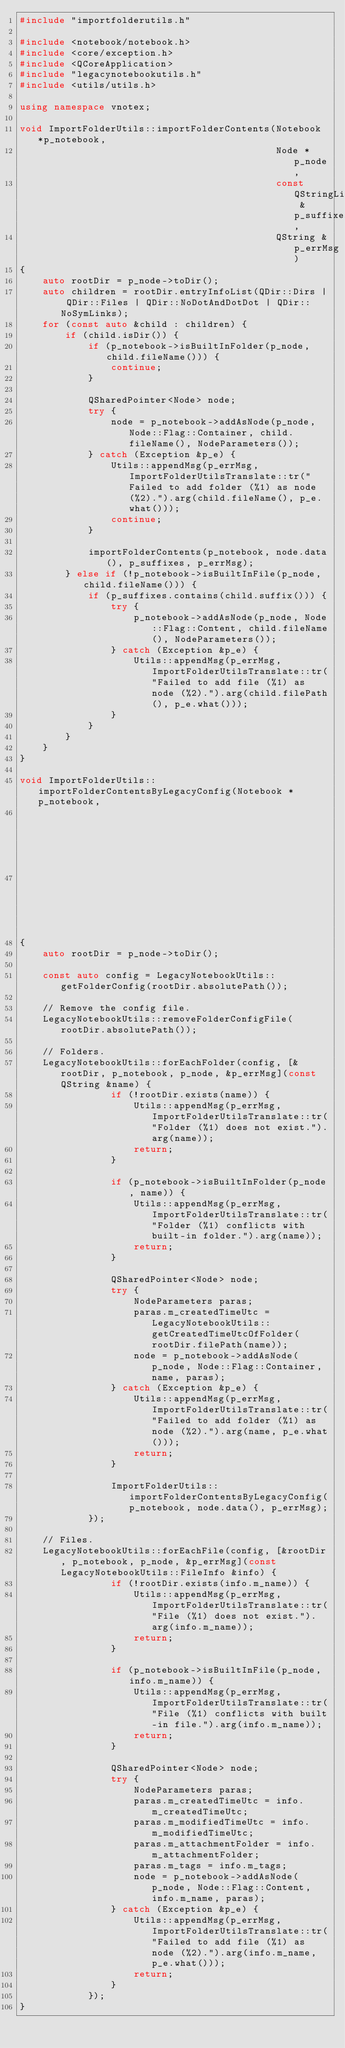<code> <loc_0><loc_0><loc_500><loc_500><_C++_>#include "importfolderutils.h"

#include <notebook/notebook.h>
#include <core/exception.h>
#include <QCoreApplication>
#include "legacynotebookutils.h"
#include <utils/utils.h>

using namespace vnotex;

void ImportFolderUtils::importFolderContents(Notebook *p_notebook,
                                             Node *p_node,
                                             const QStringList &p_suffixes,
                                             QString &p_errMsg)
{
    auto rootDir = p_node->toDir();
    auto children = rootDir.entryInfoList(QDir::Dirs | QDir::Files | QDir::NoDotAndDotDot | QDir::NoSymLinks);
    for (const auto &child : children) {
        if (child.isDir()) {
            if (p_notebook->isBuiltInFolder(p_node, child.fileName())) {
                continue;
            }

            QSharedPointer<Node> node;
            try {
                node = p_notebook->addAsNode(p_node, Node::Flag::Container, child.fileName(), NodeParameters());
            } catch (Exception &p_e) {
                Utils::appendMsg(p_errMsg, ImportFolderUtilsTranslate::tr("Failed to add folder (%1) as node (%2).").arg(child.fileName(), p_e.what()));
                continue;
            }

            importFolderContents(p_notebook, node.data(), p_suffixes, p_errMsg);
        } else if (!p_notebook->isBuiltInFile(p_node, child.fileName())) {
            if (p_suffixes.contains(child.suffix())) {
                try {
                    p_notebook->addAsNode(p_node, Node::Flag::Content, child.fileName(), NodeParameters());
                } catch (Exception &p_e) {
                    Utils::appendMsg(p_errMsg, ImportFolderUtilsTranslate::tr("Failed to add file (%1) as node (%2).").arg(child.filePath(), p_e.what()));
                }
            }
        }
    }
}

void ImportFolderUtils::importFolderContentsByLegacyConfig(Notebook *p_notebook,
                                                           Node *p_node,
                                                           QString &p_errMsg)
{
    auto rootDir = p_node->toDir();

    const auto config = LegacyNotebookUtils::getFolderConfig(rootDir.absolutePath());

    // Remove the config file.
    LegacyNotebookUtils::removeFolderConfigFile(rootDir.absolutePath());

    // Folders.
    LegacyNotebookUtils::forEachFolder(config, [&rootDir, p_notebook, p_node, &p_errMsg](const QString &name) {
                if (!rootDir.exists(name)) {
                    Utils::appendMsg(p_errMsg, ImportFolderUtilsTranslate::tr("Folder (%1) does not exist.").arg(name));
                    return;
                }

                if (p_notebook->isBuiltInFolder(p_node, name)) {
                    Utils::appendMsg(p_errMsg, ImportFolderUtilsTranslate::tr("Folder (%1) conflicts with built-in folder.").arg(name));
                    return;
                }

                QSharedPointer<Node> node;
                try {
                    NodeParameters paras;
                    paras.m_createdTimeUtc = LegacyNotebookUtils::getCreatedTimeUtcOfFolder(rootDir.filePath(name));
                    node = p_notebook->addAsNode(p_node, Node::Flag::Container, name, paras);
                } catch (Exception &p_e) {
                    Utils::appendMsg(p_errMsg, ImportFolderUtilsTranslate::tr("Failed to add folder (%1) as node (%2).").arg(name, p_e.what()));
                    return;
                }

                ImportFolderUtils::importFolderContentsByLegacyConfig(p_notebook, node.data(), p_errMsg);
            });

    // Files.
    LegacyNotebookUtils::forEachFile(config, [&rootDir, p_notebook, p_node, &p_errMsg](const LegacyNotebookUtils::FileInfo &info) {
                if (!rootDir.exists(info.m_name)) {
                    Utils::appendMsg(p_errMsg, ImportFolderUtilsTranslate::tr("File (%1) does not exist.").arg(info.m_name));
                    return;
                }

                if (p_notebook->isBuiltInFile(p_node, info.m_name)) {
                    Utils::appendMsg(p_errMsg, ImportFolderUtilsTranslate::tr("File (%1) conflicts with built-in file.").arg(info.m_name));
                    return;
                }

                QSharedPointer<Node> node;
                try {
                    NodeParameters paras;
                    paras.m_createdTimeUtc = info.m_createdTimeUtc;
                    paras.m_modifiedTimeUtc = info.m_modifiedTimeUtc;
                    paras.m_attachmentFolder = info.m_attachmentFolder;
                    paras.m_tags = info.m_tags;
                    node = p_notebook->addAsNode(p_node, Node::Flag::Content, info.m_name, paras);
                } catch (Exception &p_e) {
                    Utils::appendMsg(p_errMsg, ImportFolderUtilsTranslate::tr("Failed to add file (%1) as node (%2).").arg(info.m_name, p_e.what()));
                    return;
                }
            });
}
</code> 